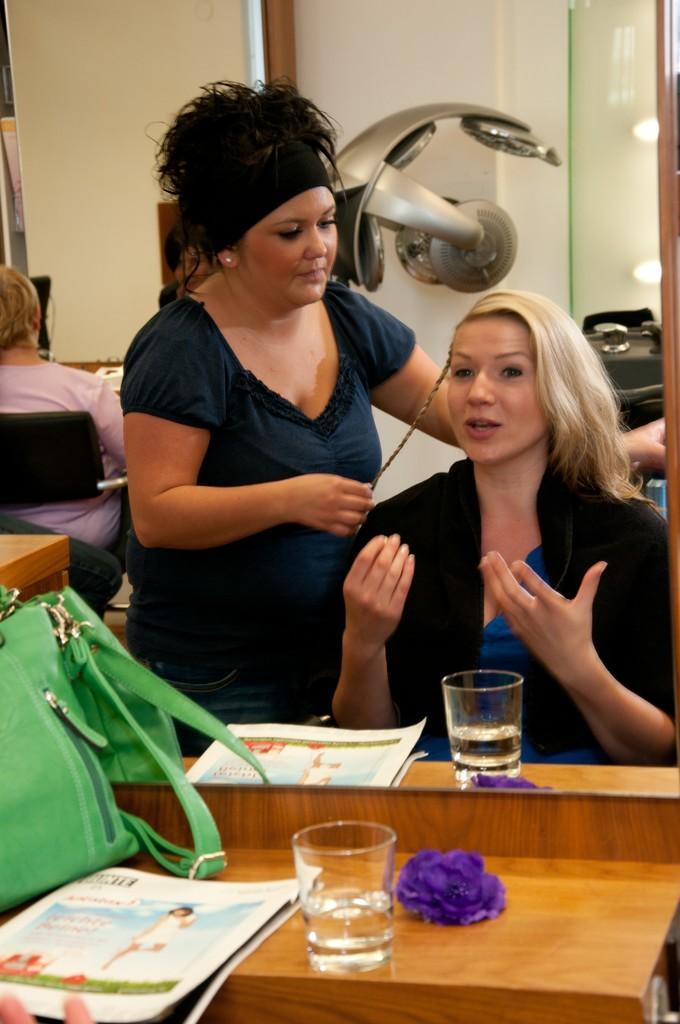How would you summarize this image in a sentence or two? In this picture we can see two ladies sitting on the chair in front of the mirror and on the mirror desk we have a bag, paper and a glass. 